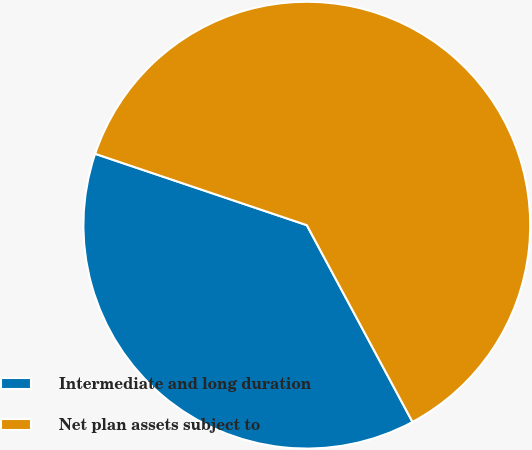Convert chart to OTSL. <chart><loc_0><loc_0><loc_500><loc_500><pie_chart><fcel>Intermediate and long duration<fcel>Net plan assets subject to<nl><fcel>38.02%<fcel>61.98%<nl></chart> 